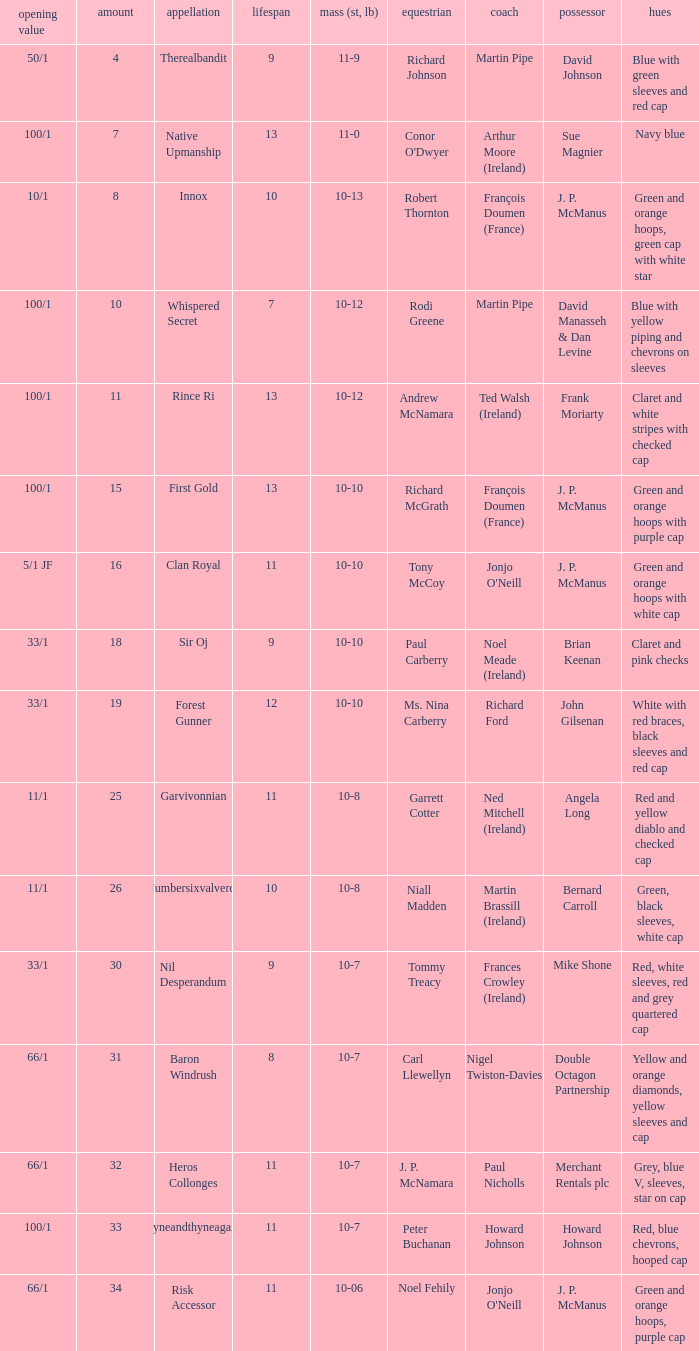What was the name of the entrant with an owner named David Johnson? Therealbandit. 